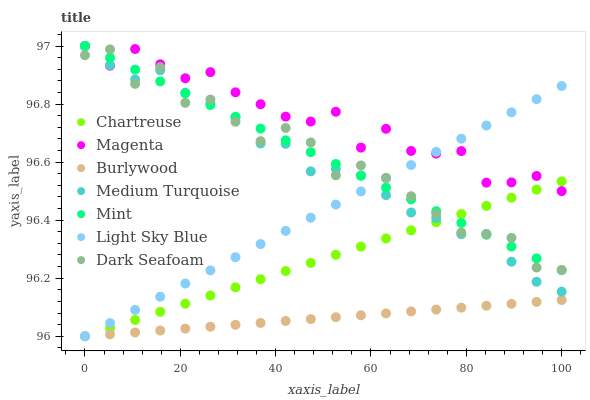Does Burlywood have the minimum area under the curve?
Answer yes or no. Yes. Does Magenta have the maximum area under the curve?
Answer yes or no. Yes. Does Dark Seafoam have the minimum area under the curve?
Answer yes or no. No. Does Dark Seafoam have the maximum area under the curve?
Answer yes or no. No. Is Chartreuse the smoothest?
Answer yes or no. Yes. Is Dark Seafoam the roughest?
Answer yes or no. Yes. Is Dark Seafoam the smoothest?
Answer yes or no. No. Is Chartreuse the roughest?
Answer yes or no. No. Does Burlywood have the lowest value?
Answer yes or no. Yes. Does Dark Seafoam have the lowest value?
Answer yes or no. No. Does Mint have the highest value?
Answer yes or no. Yes. Does Dark Seafoam have the highest value?
Answer yes or no. No. Is Burlywood less than Magenta?
Answer yes or no. Yes. Is Medium Turquoise greater than Burlywood?
Answer yes or no. Yes. Does Light Sky Blue intersect Magenta?
Answer yes or no. Yes. Is Light Sky Blue less than Magenta?
Answer yes or no. No. Is Light Sky Blue greater than Magenta?
Answer yes or no. No. Does Burlywood intersect Magenta?
Answer yes or no. No. 